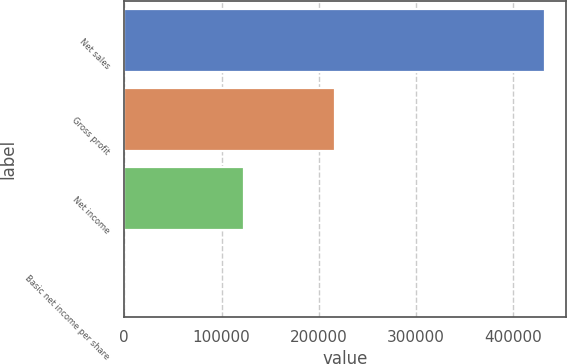Convert chart to OTSL. <chart><loc_0><loc_0><loc_500><loc_500><bar_chart><fcel>Net sales<fcel>Gross profit<fcel>Net income<fcel>Basic net income per share<nl><fcel>432468<fcel>216284<fcel>123286<fcel>0.57<nl></chart> 